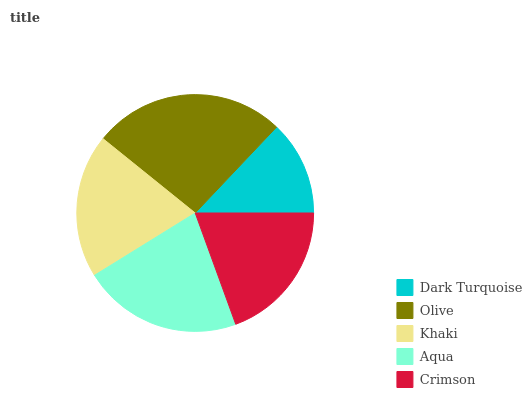Is Dark Turquoise the minimum?
Answer yes or no. Yes. Is Olive the maximum?
Answer yes or no. Yes. Is Khaki the minimum?
Answer yes or no. No. Is Khaki the maximum?
Answer yes or no. No. Is Olive greater than Khaki?
Answer yes or no. Yes. Is Khaki less than Olive?
Answer yes or no. Yes. Is Khaki greater than Olive?
Answer yes or no. No. Is Olive less than Khaki?
Answer yes or no. No. Is Khaki the high median?
Answer yes or no. Yes. Is Khaki the low median?
Answer yes or no. Yes. Is Crimson the high median?
Answer yes or no. No. Is Olive the low median?
Answer yes or no. No. 